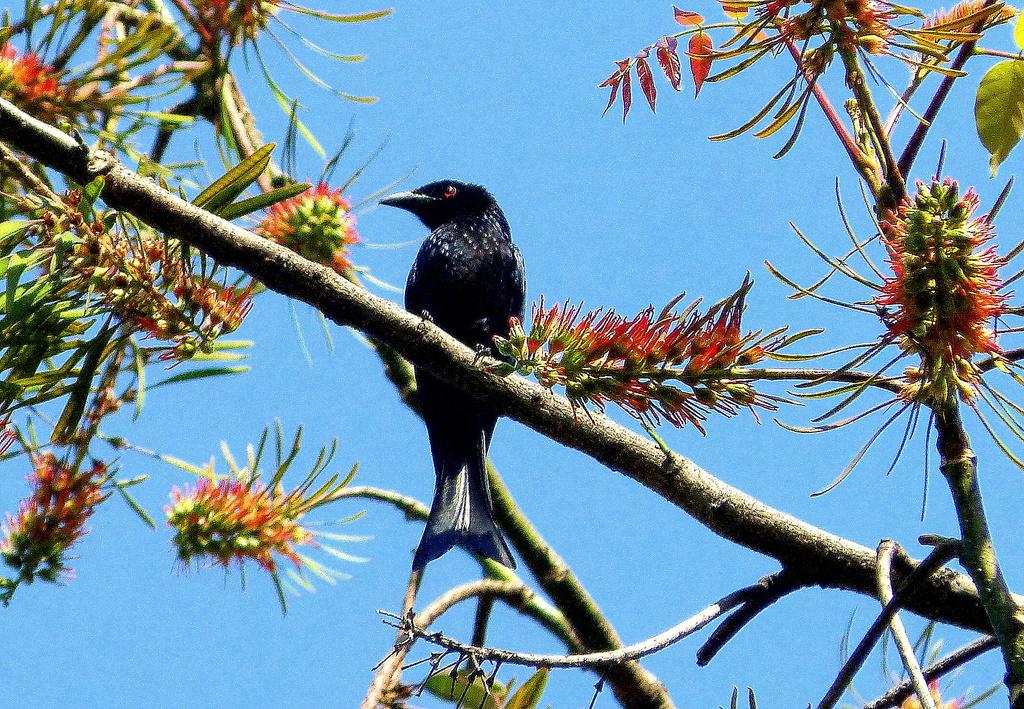What type of animal can be seen on the tree in the image? There is a bird visible on the trunk of a tree in the image. What is the current state of the tree's growth? The tree has buds and leaves, indicating that it is growing. What is visible at the top of the image? The sky is visible at the top of the image. What route does the steam take as it travels along the coast in the image? There is no steam or coast present in the image; it features a bird on a tree with buds and leaves. 